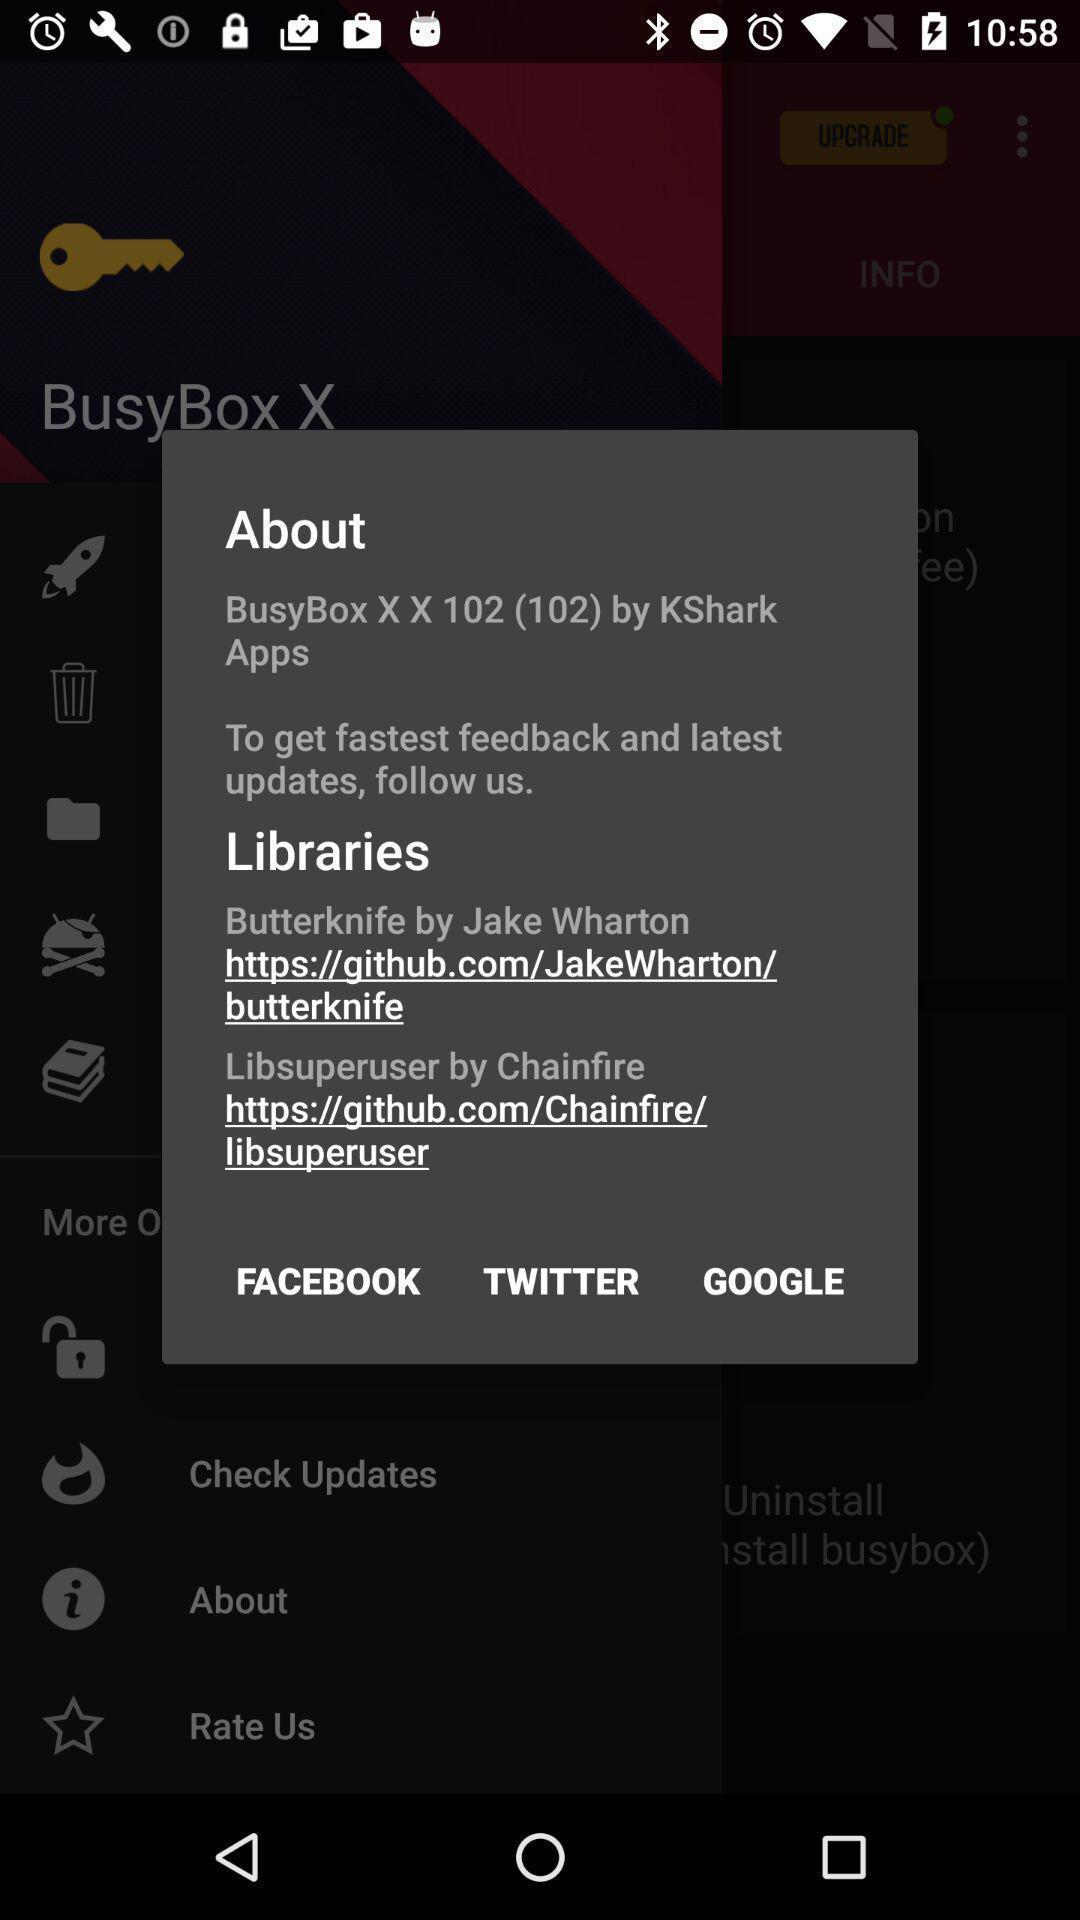Describe the content in this image. Pop up to display the features. 